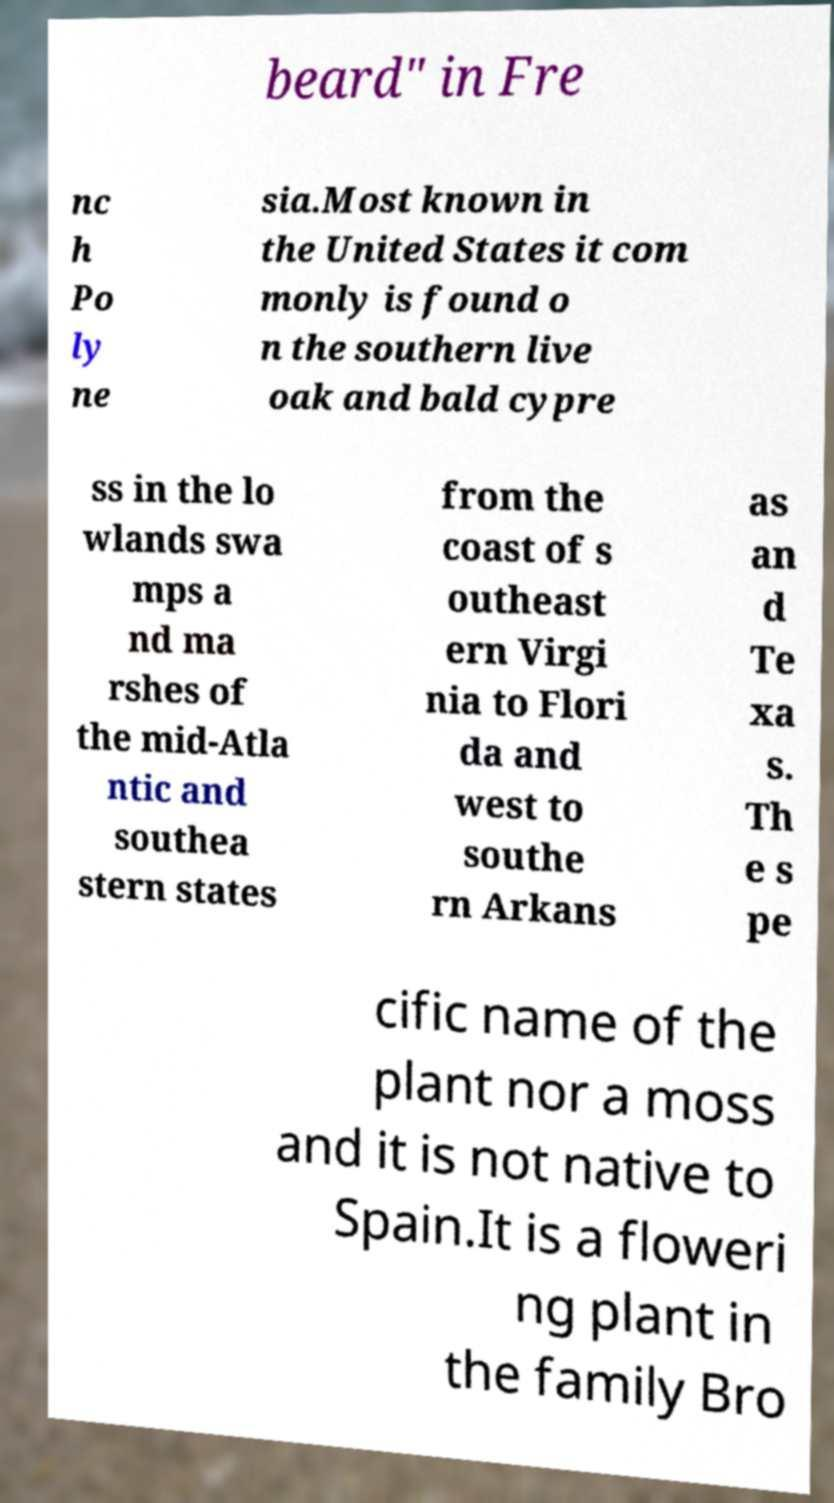Can you accurately transcribe the text from the provided image for me? beard" in Fre nc h Po ly ne sia.Most known in the United States it com monly is found o n the southern live oak and bald cypre ss in the lo wlands swa mps a nd ma rshes of the mid-Atla ntic and southea stern states from the coast of s outheast ern Virgi nia to Flori da and west to southe rn Arkans as an d Te xa s. Th e s pe cific name of the plant nor a moss and it is not native to Spain.It is a floweri ng plant in the family Bro 